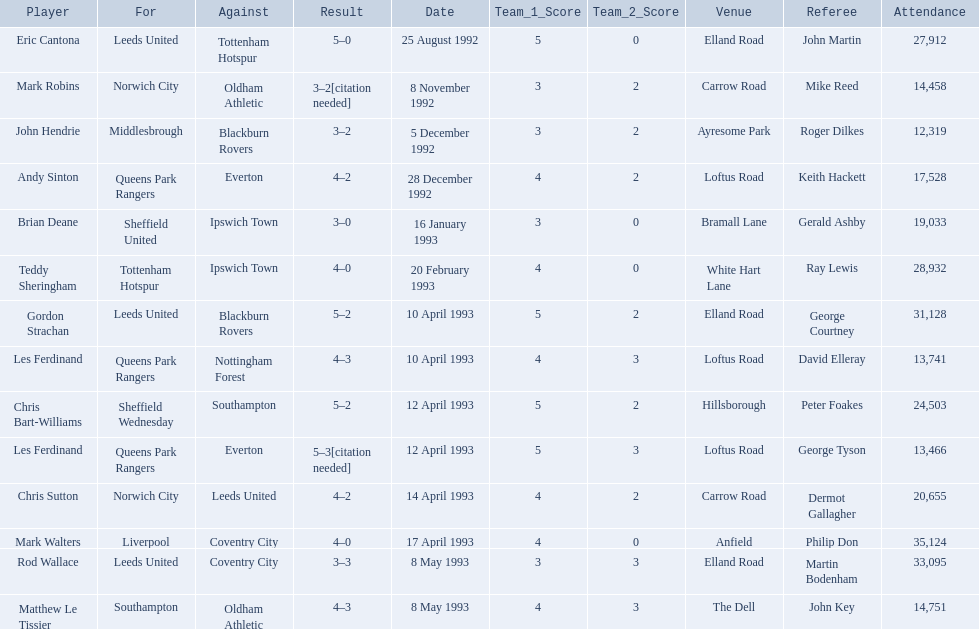Who are the players in 1992-93 fa premier league? Eric Cantona, Mark Robins, John Hendrie, Andy Sinton, Brian Deane, Teddy Sheringham, Gordon Strachan, Les Ferdinand, Chris Bart-Williams, Les Ferdinand, Chris Sutton, Mark Walters, Rod Wallace, Matthew Le Tissier. What is mark robins' result? 3–2[citation needed]. Which player has the same result? John Hendrie. 